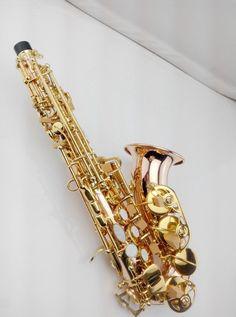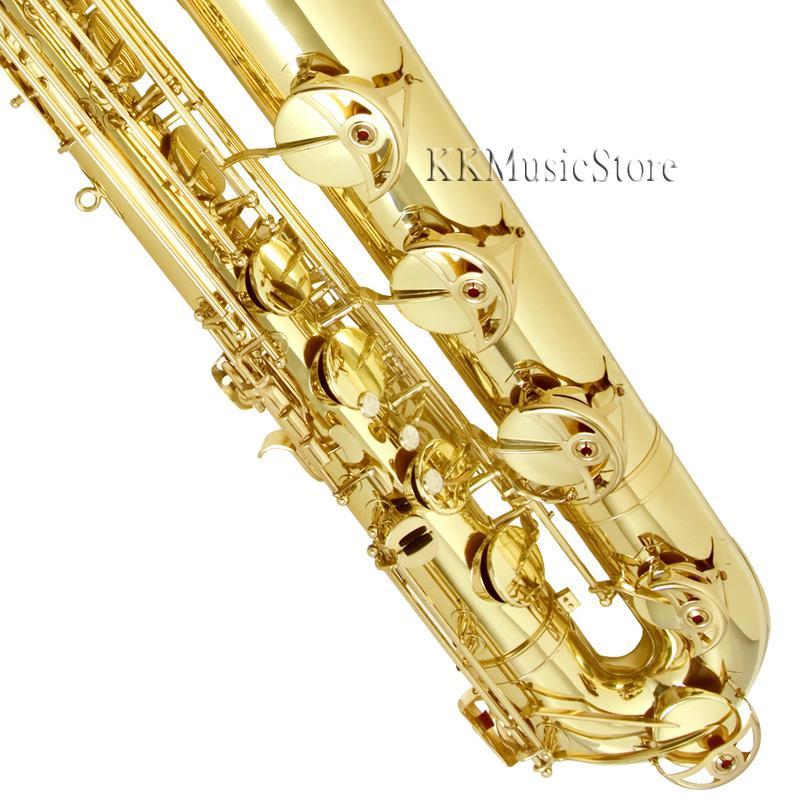The first image is the image on the left, the second image is the image on the right. Examine the images to the left and right. Is the description "A tag is connected to the sax in the image on the right." accurate? Answer yes or no. No. The first image is the image on the left, the second image is the image on the right. Considering the images on both sides, is "One of the images shows a saxophone and a pamphlet while the other shows only a saxophone." valid? Answer yes or no. No. 